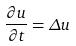<formula> <loc_0><loc_0><loc_500><loc_500>\frac { \partial u } { \partial t } = \Delta u</formula> 